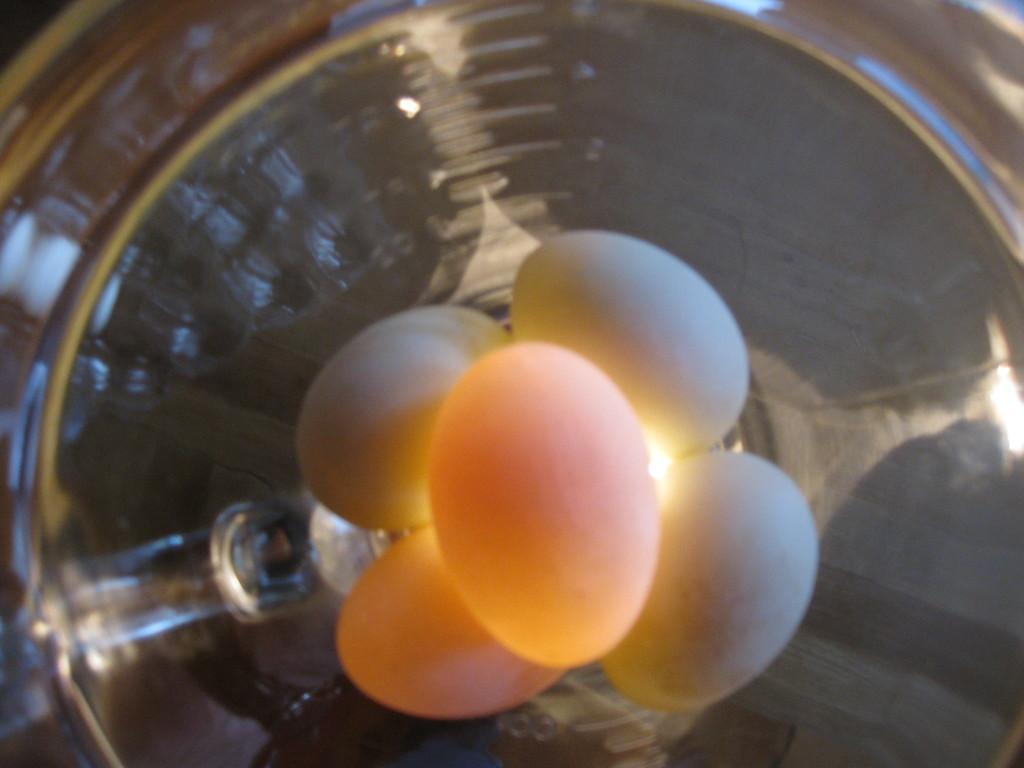Could you give a brief overview of what you see in this image? In this picture we can see eggs in a container. 